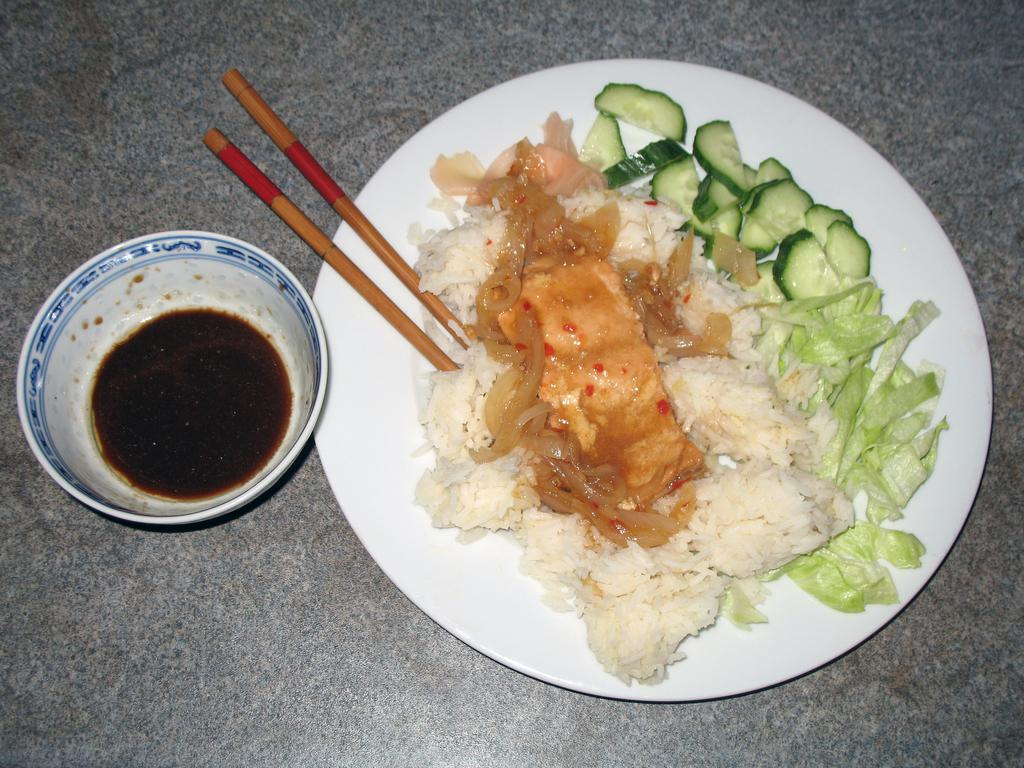What is present on the plate in the image? Food is arranged on the plate in the image. What utensils are visible in the image? There are two chopsticks beside the plate. What is the cup in the image filled with? The cup in the image is filled with sauce. How many apples are in the crib in the image? There is no crib or apples present in the image. What type of account is being discussed in the image? There is no account being discussed in the image. 